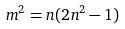Convert formula to latex. <formula><loc_0><loc_0><loc_500><loc_500>m ^ { 2 } = n ( 2 n ^ { 2 } - 1 )</formula> 